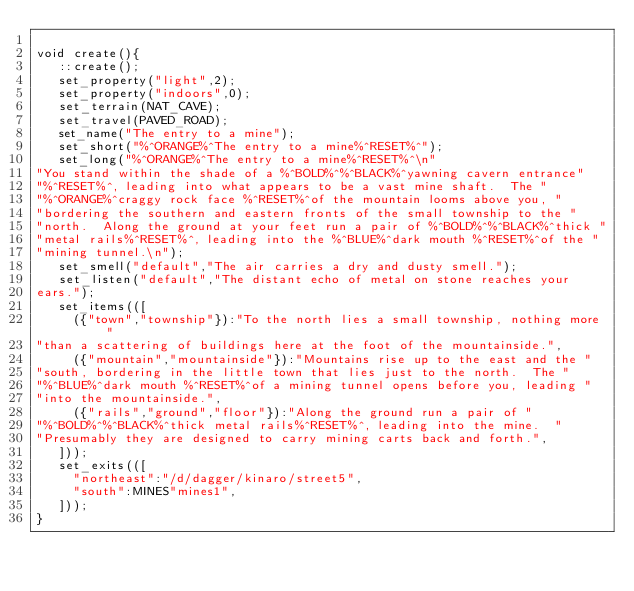<code> <loc_0><loc_0><loc_500><loc_500><_C_>
void create(){ 
   ::create();
   set_property("light",2);
   set_property("indoors",0);
   set_terrain(NAT_CAVE);
   set_travel(PAVED_ROAD);
   set_name("The entry to a mine");
   set_short("%^ORANGE%^The entry to a mine%^RESET%^");
   set_long("%^ORANGE%^The entry to a mine%^RESET%^\n"
"You stand within the shade of a %^BOLD%^%^BLACK%^yawning cavern entrance"
"%^RESET%^, leading into what appears to be a vast mine shaft.  The "
"%^ORANGE%^craggy rock face %^RESET%^of the mountain looms above you, "
"bordering the southern and eastern fronts of the small township to the "
"north.  Along the ground at your feet run a pair of %^BOLD%^%^BLACK%^thick "
"metal rails%^RESET%^, leading into the %^BLUE%^dark mouth %^RESET%^of the "
"mining tunnel.\n");
   set_smell("default","The air carries a dry and dusty smell.");
   set_listen("default","The distant echo of metal on stone reaches your 
ears.");
   set_items(([
     ({"town","township"}):"To the north lies a small township, nothing more "
"than a scattering of buildings here at the foot of the mountainside.",
     ({"mountain","mountainside"}):"Mountains rise up to the east and the "
"south, bordering in the little town that lies just to the north.  The "
"%^BLUE%^dark mouth %^RESET%^of a mining tunnel opens before you, leading "
"into the mountainside.",
     ({"rails","ground","floor"}):"Along the ground run a pair of "
"%^BOLD%^%^BLACK%^thick metal rails%^RESET%^, leading into the mine.  "
"Presumably they are designed to carry mining carts back and forth.",
   ]));
   set_exits(([
     "northeast":"/d/dagger/kinaro/street5",
     "south":MINES"mines1",
   ]));
}
</code> 